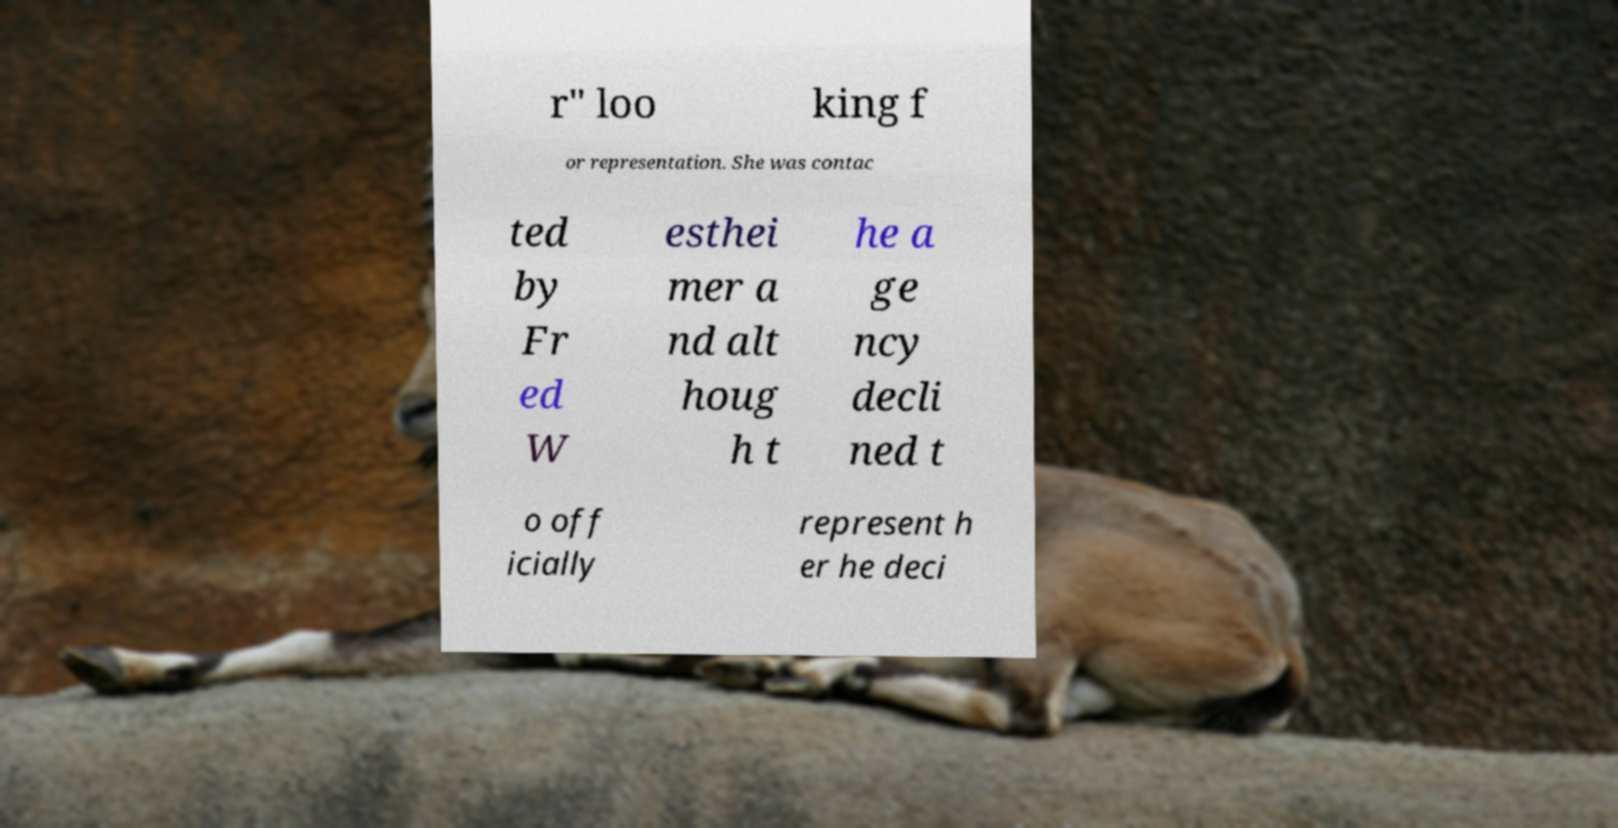What messages or text are displayed in this image? I need them in a readable, typed format. r" loo king f or representation. She was contac ted by Fr ed W esthei mer a nd alt houg h t he a ge ncy decli ned t o off icially represent h er he deci 